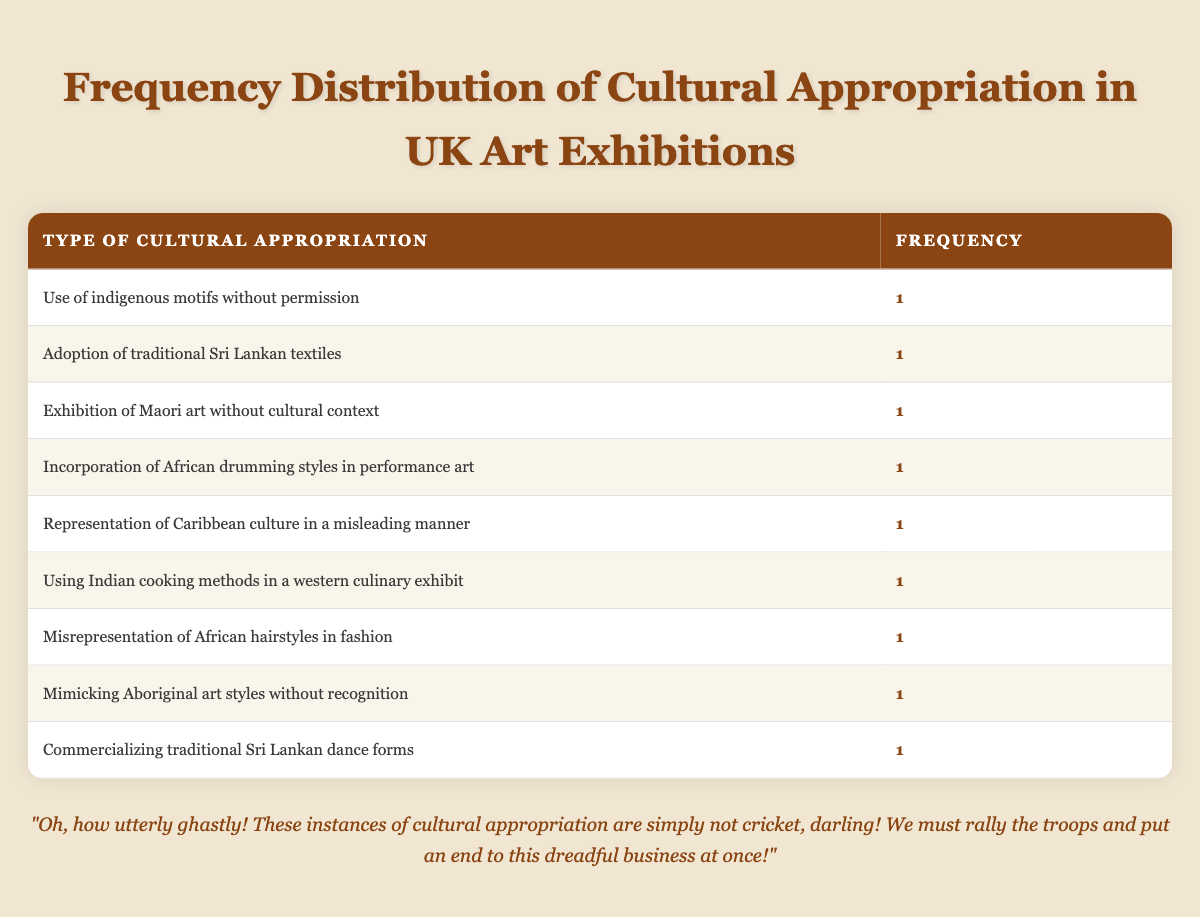What type of cultural appropriation is associated with the exhibition "Diversity in Dialogue"? The table shows that "Diversity in Dialogue," by Isabella Browne, is linked to the cultural appropriation type "Use of indigenous motifs without permission." This information is extracted directly from the corresponding row in the table under the exhibition name column.
Answer: Use of indigenous motifs without permission How many instances of cultural appropriation type are listed in the table? Each row in the table represents a unique instance of cultural appropriation type. There are a total of 9 rows in the table, which means there are 9 distinct instances of cultural appropriation type reported.
Answer: 9 Is there any exhibition that features the commercialization of traditional Sri Lankan dance forms? The data reveals that "Cultural Showdown," by Rajesh Gunawardena, involves the cultural appropriation type "Commercializing traditional Sri Lankan dance forms." Thus, the answer is yes; this fact is indeed present in the table.
Answer: Yes Which year had the most recent instance of cultural appropriation noted in the table? The table shows that the most recent year recorded is 2023, associated with "Colonial Legacies" and "Beyond Borders." This is determined by scanning the year column in each row.
Answer: 2023 What is the common frequency of each cultural appropriation type listed? All cultural appropriation types mentioned have a frequency of 1. Counting the occurrences in the frequency column confirms this, as each row indicates a frequency of 1.
Answer: 1 How many exhibitions were held in 2022? From the table, the exhibitions "Eastern Echoes" and "Artistic Crossroads" are the only two listed for the year 2022. By identifying and counting the respective rows for that year, the number is clearly established.
Answer: 2 Is the representation of Caribbean culture considered misleading according to the data? According to the table, "Colonial Legacies" involves "Representation of Caribbean culture in a misleading manner," which confirms that this type of representation is indeed considered misleading according to the data presented.
Answer: Yes If we categorize the cultural appropriation types, do more than one instance involve traditional Sri Lankan culture? Upon examining the table, there are two instances linked to traditional Sri Lankan culture: "Adoption of traditional Sri Lankan textiles" and "Commercializing traditional Sri Lankan dance forms." Therefore, the answer involves concluding that indeed, there are multiple instances involving this specific culture.
Answer: Yes What is the ratio of exhibitions located in Cardiff to those in Liverpool? The table lists "Colonial Legacies" in Cardiff and "Fusion Identities" in Liverpool. Thus, there is 1 exhibition in Cardiff and 1 in Liverpool. The ratio of exhibitions is therefore 1:1.
Answer: 1:1 